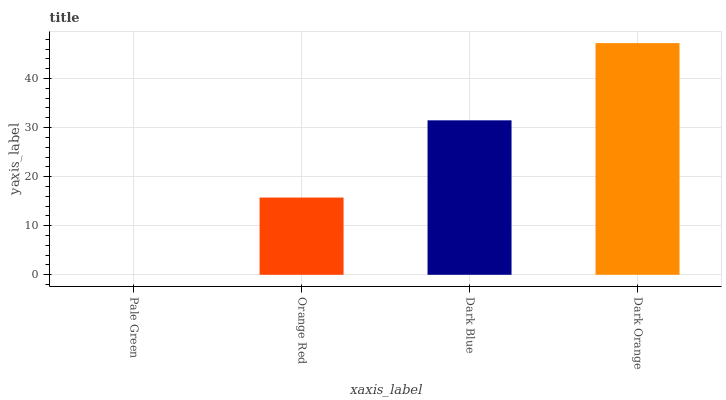Is Pale Green the minimum?
Answer yes or no. Yes. Is Dark Orange the maximum?
Answer yes or no. Yes. Is Orange Red the minimum?
Answer yes or no. No. Is Orange Red the maximum?
Answer yes or no. No. Is Orange Red greater than Pale Green?
Answer yes or no. Yes. Is Pale Green less than Orange Red?
Answer yes or no. Yes. Is Pale Green greater than Orange Red?
Answer yes or no. No. Is Orange Red less than Pale Green?
Answer yes or no. No. Is Dark Blue the high median?
Answer yes or no. Yes. Is Orange Red the low median?
Answer yes or no. Yes. Is Orange Red the high median?
Answer yes or no. No. Is Dark Blue the low median?
Answer yes or no. No. 